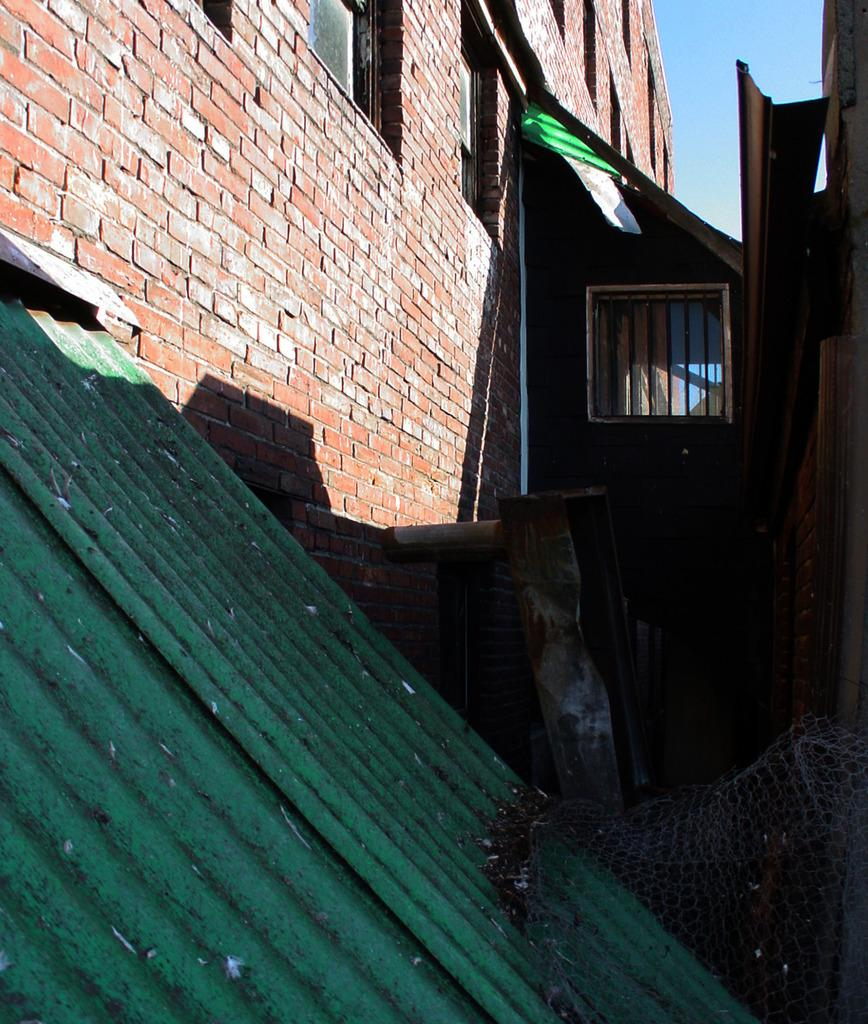What type of protective structures are present in the image? There are roof shields in the image. What type of structure is depicted in the image? There is a building with windows in the image. What else can be seen in the image besides the roof shields and building? There are objects visible in the image. What can be seen in the background of the image? The sky is visible in the background of the image. What riddle is written on the roof shields in the image? There is no riddle written on the roof shields in the image. What position does the building hold in the image? The building is a main subject in the image, but there is no specific position mentioned. 